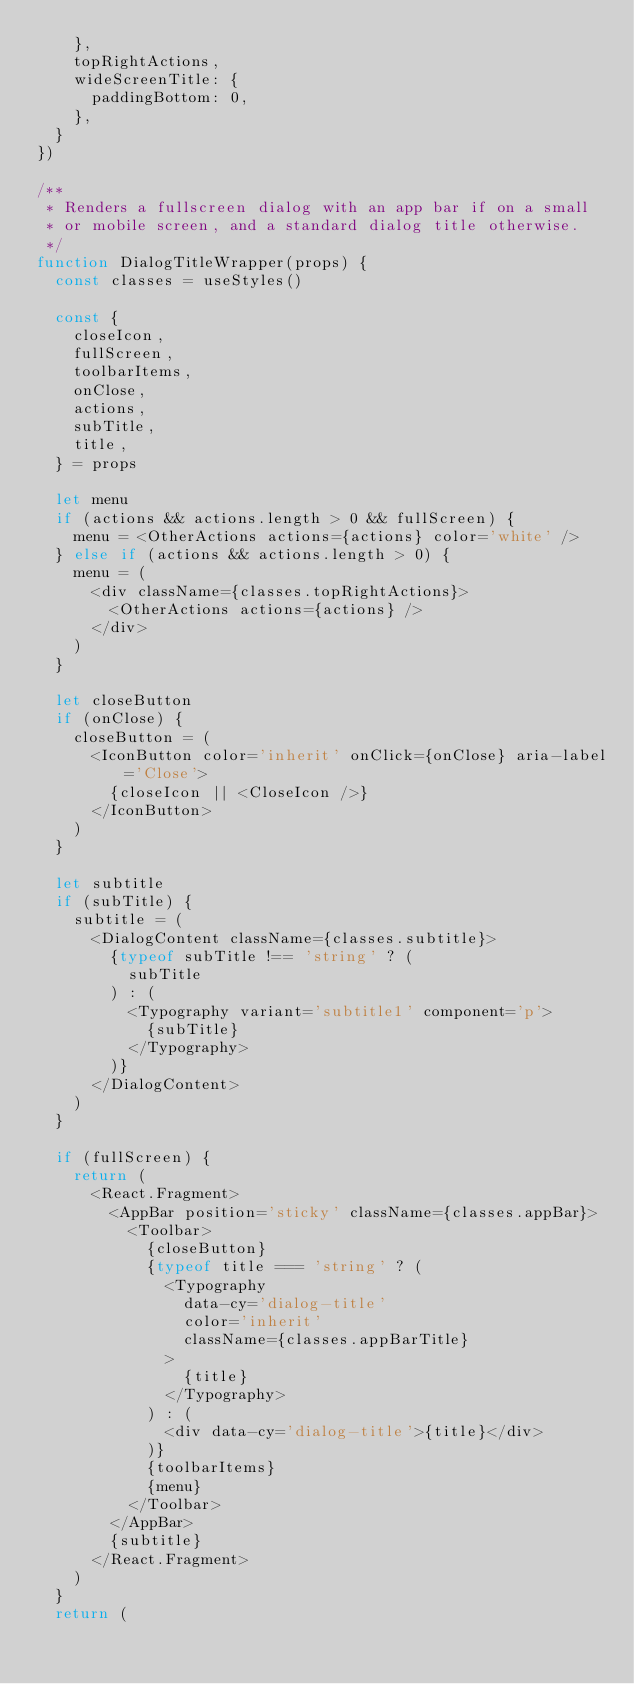Convert code to text. <code><loc_0><loc_0><loc_500><loc_500><_JavaScript_>    },
    topRightActions,
    wideScreenTitle: {
      paddingBottom: 0,
    },
  }
})

/**
 * Renders a fullscreen dialog with an app bar if on a small
 * or mobile screen, and a standard dialog title otherwise.
 */
function DialogTitleWrapper(props) {
  const classes = useStyles()

  const {
    closeIcon,
    fullScreen,
    toolbarItems,
    onClose,
    actions,
    subTitle,
    title,
  } = props

  let menu
  if (actions && actions.length > 0 && fullScreen) {
    menu = <OtherActions actions={actions} color='white' />
  } else if (actions && actions.length > 0) {
    menu = (
      <div className={classes.topRightActions}>
        <OtherActions actions={actions} />
      </div>
    )
  }

  let closeButton
  if (onClose) {
    closeButton = (
      <IconButton color='inherit' onClick={onClose} aria-label='Close'>
        {closeIcon || <CloseIcon />}
      </IconButton>
    )
  }

  let subtitle
  if (subTitle) {
    subtitle = (
      <DialogContent className={classes.subtitle}>
        {typeof subTitle !== 'string' ? (
          subTitle
        ) : (
          <Typography variant='subtitle1' component='p'>
            {subTitle}
          </Typography>
        )}
      </DialogContent>
    )
  }

  if (fullScreen) {
    return (
      <React.Fragment>
        <AppBar position='sticky' className={classes.appBar}>
          <Toolbar>
            {closeButton}
            {typeof title === 'string' ? (
              <Typography
                data-cy='dialog-title'
                color='inherit'
                className={classes.appBarTitle}
              >
                {title}
              </Typography>
            ) : (
              <div data-cy='dialog-title'>{title}</div>
            )}
            {toolbarItems}
            {menu}
          </Toolbar>
        </AppBar>
        {subtitle}
      </React.Fragment>
    )
  }
  return (</code> 